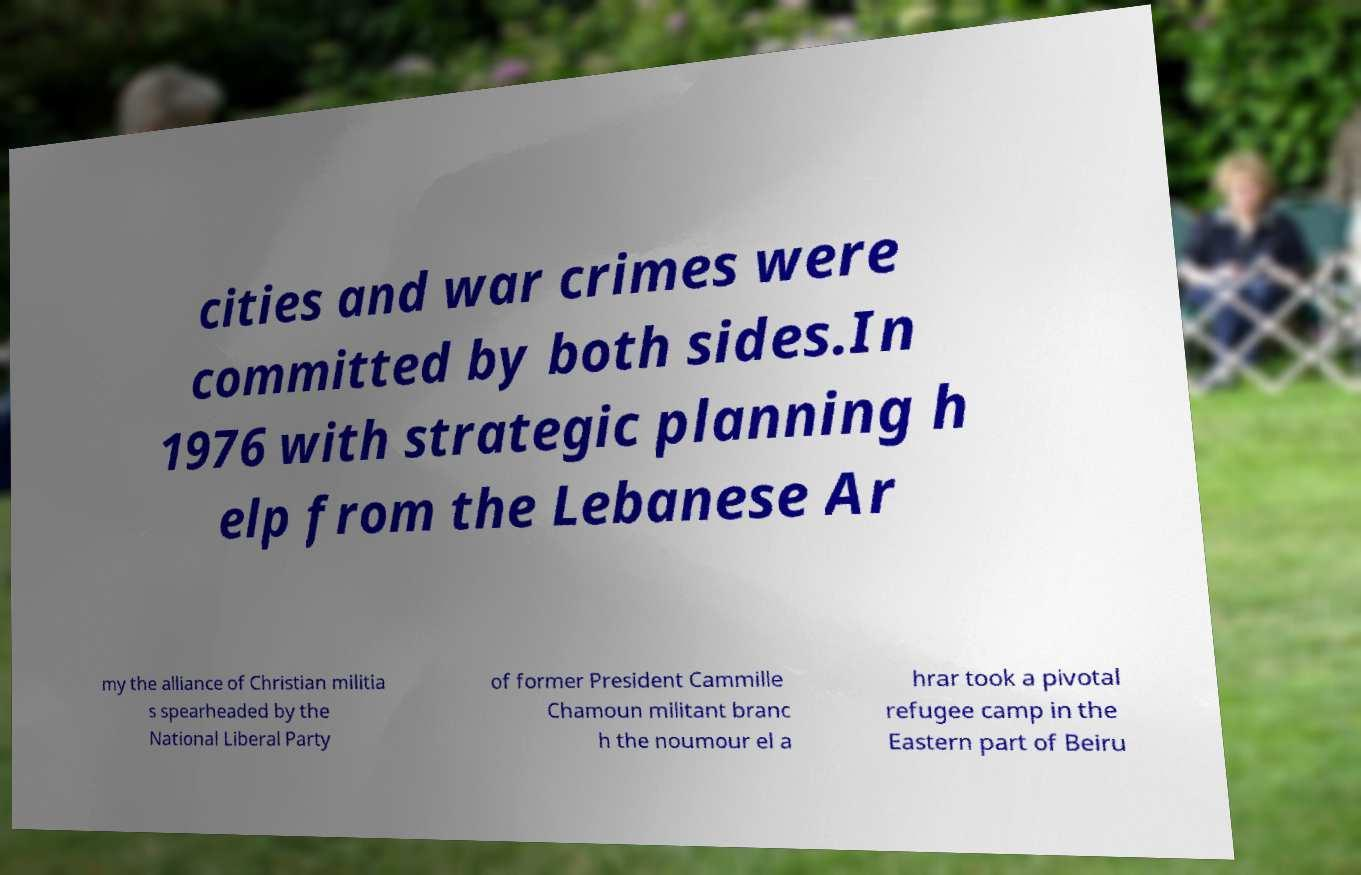Please identify and transcribe the text found in this image. cities and war crimes were committed by both sides.In 1976 with strategic planning h elp from the Lebanese Ar my the alliance of Christian militia s spearheaded by the National Liberal Party of former President Cammille Chamoun militant branc h the noumour el a hrar took a pivotal refugee camp in the Eastern part of Beiru 